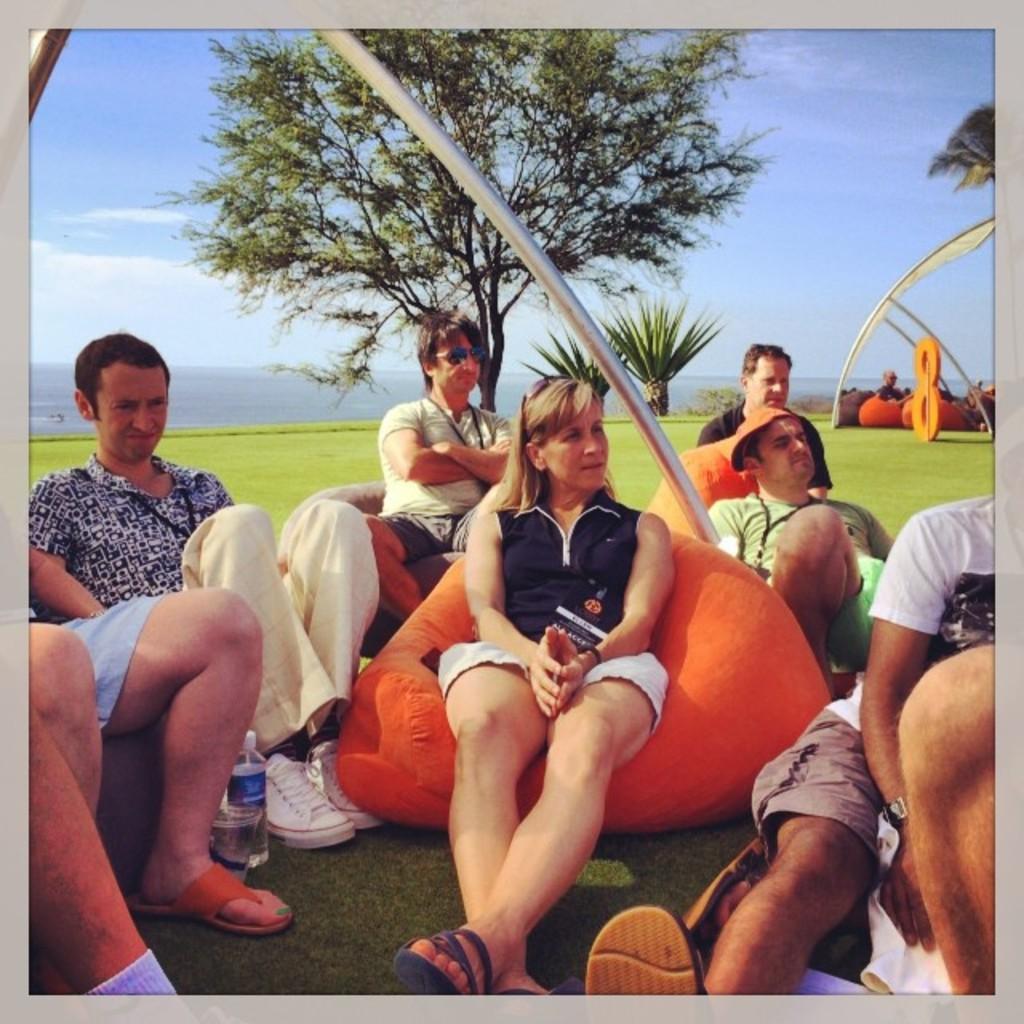Please provide a concise description of this image. In the foreground of this image, there are persons sitting on the bean bags and we can also see a bottle on the grass. They are sitting under the shelter like an object. In the background, there is a man sitting under the shelter like an object, few trees, water, sky and the cloud. 